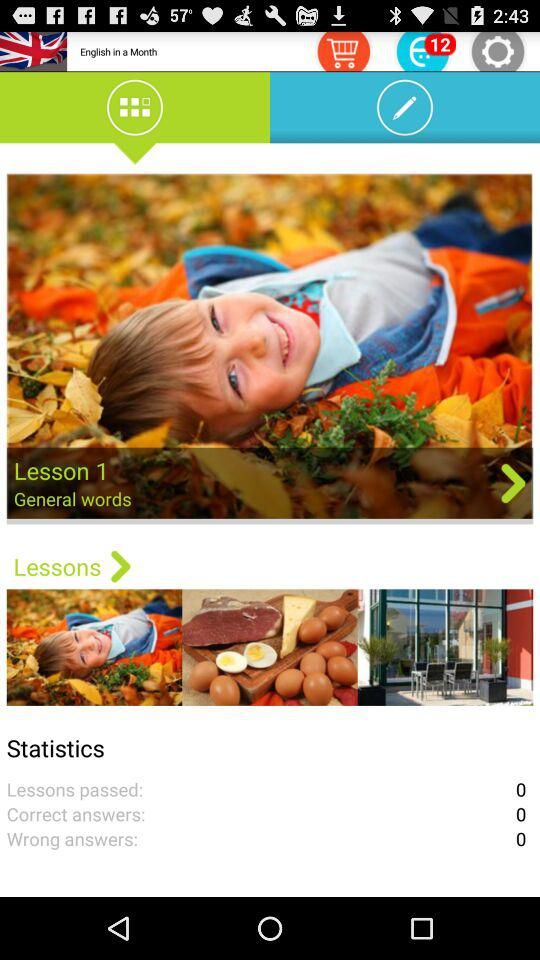How many answers are correct? There are 0 correct answers. 